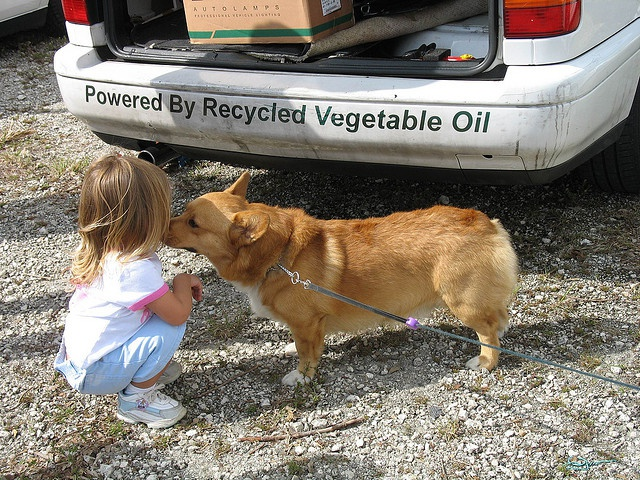Describe the objects in this image and their specific colors. I can see truck in darkgray, lightgray, black, and gray tones, dog in darkgray, maroon, olive, and tan tones, and people in darkgray, white, gray, and maroon tones in this image. 